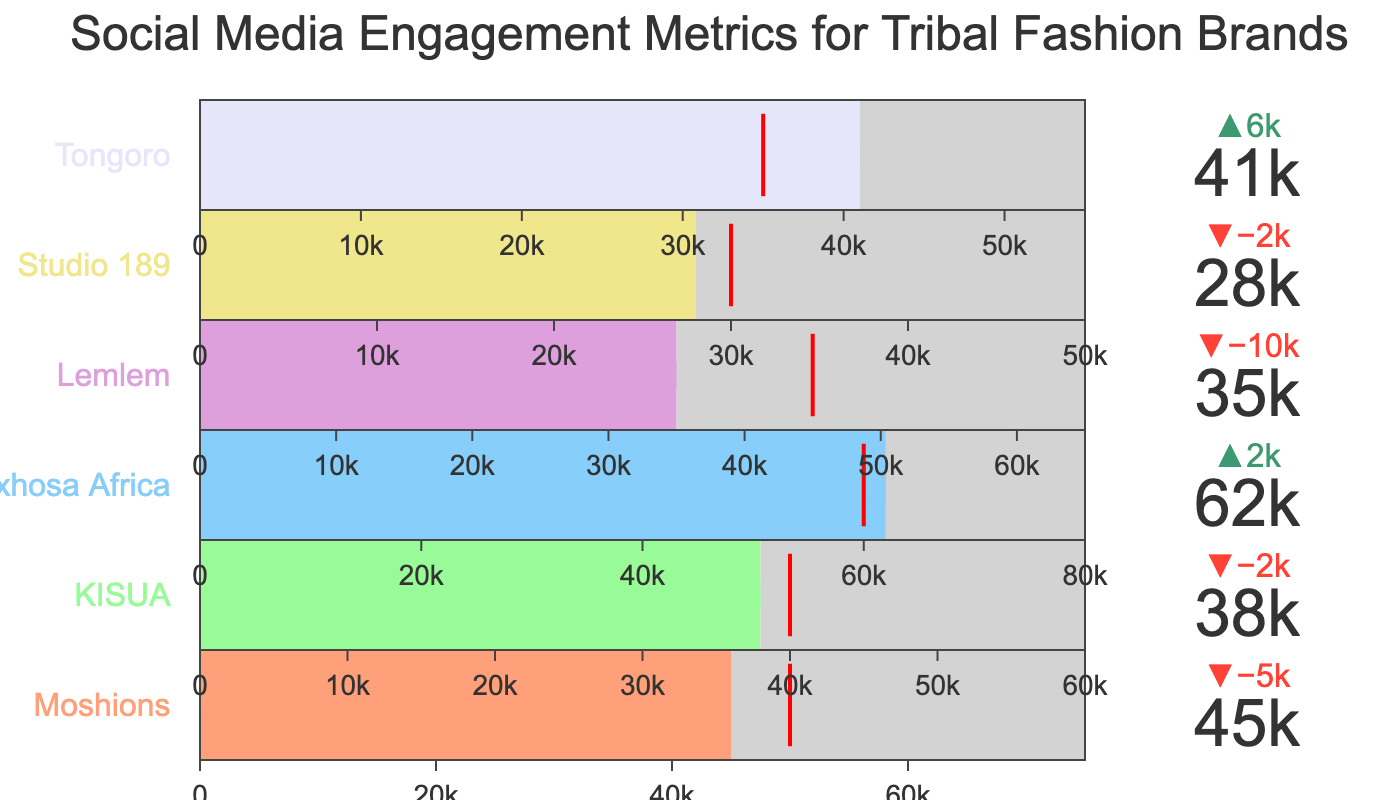What is the title of the figure? The title is usually found at the top of the plot and provides an overview of what the data represents. In this case, it is "Social Media Engagement Metrics for Tribal Fashion Brands".
Answer: Social Media Engagement Metrics for Tribal Fashion Brands How many fashion brands are included in this chart? Count the number of individual bullet charts or trace names listed in the chart, which correspond to the different brands.
Answer: 6 Which brand has the highest actual engagement? Identify the section in each bullet chart indicating 'Actual Engagement' and determine which brand has the highest value. 'Maxhosa Africa' shows 62000, which is the highest.
Answer: Maxhosa Africa Which brand achieved its target engagement? Compare the 'Actual Engagement' values to the 'Target Engagement' values for each brand. 'Maxhosa Africa' has 'Actual Engagement' equal to its 'Target Engagement', which is 62000.
Answer: Maxhosa Africa What is the color of the bar representing 'Moshions'? Look at the bar within the 'Moshions' bullet graph. According to the code, each brand has a specific color from the colors list. 'Moshions' is the first in the list which corresponds to '#FFA07A' (light salmon color).
Answer: Light salmon Which brand has the smallest difference between its actual and target engagement? Calculate the difference between 'Actual Engagement' and 'Target Engagement' for each brand. 'KISUA' has the smallest difference of 2000 (40000 - 38000).
Answer: KISUA How many brands exceed their target engagement? Count the number of instances where 'Actual Engagement' is greater than 'Target Engagement' for each brand. 'Moshions', 'Maxhosa Africa', 'Tongoro' exceed their target engagements.
Answer: 3 Which brand came closest to its maximum engagement? Compare the difference between 'Actual Engagement' and 'Maximum Engagement' for each brand. 'Maxhosa Africa' has the closest value with a difference of 180000 (80000 - 62000).
Answer: Maxhosa Africa Which brands did not reach their target engagement? Identify 'Actual Engagement' values that are lower than 'Target Engagement'. 'Lemlem' and 'Studio 189' did not reach their target.
Answer: Lemlem, Studio 189 What is the total actual engagement across all brands? Sum the 'Actual Engagement' values for all the brands: 45000+38000+62000+35000+28000+41000 = 249000.
Answer: 249000 